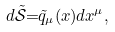Convert formula to latex. <formula><loc_0><loc_0><loc_500><loc_500>d \mathcal { \tilde { S } } \mathcal { = } \tilde { q } _ { \mu } ( x ) d x ^ { \mu } ,</formula> 